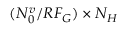<formula> <loc_0><loc_0><loc_500><loc_500>( N _ { 0 } ^ { v } / R F _ { G } ) \times N _ { H }</formula> 